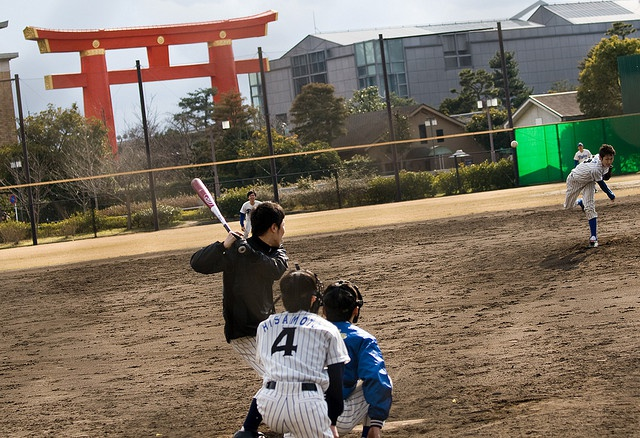Describe the objects in this image and their specific colors. I can see people in lightgray, darkgray, and black tones, people in lightgray, black, gray, and maroon tones, people in lightgray, black, navy, gray, and blue tones, people in lightgray, gray, black, and darkgray tones, and baseball bat in lightgray, white, brown, and darkgray tones in this image. 